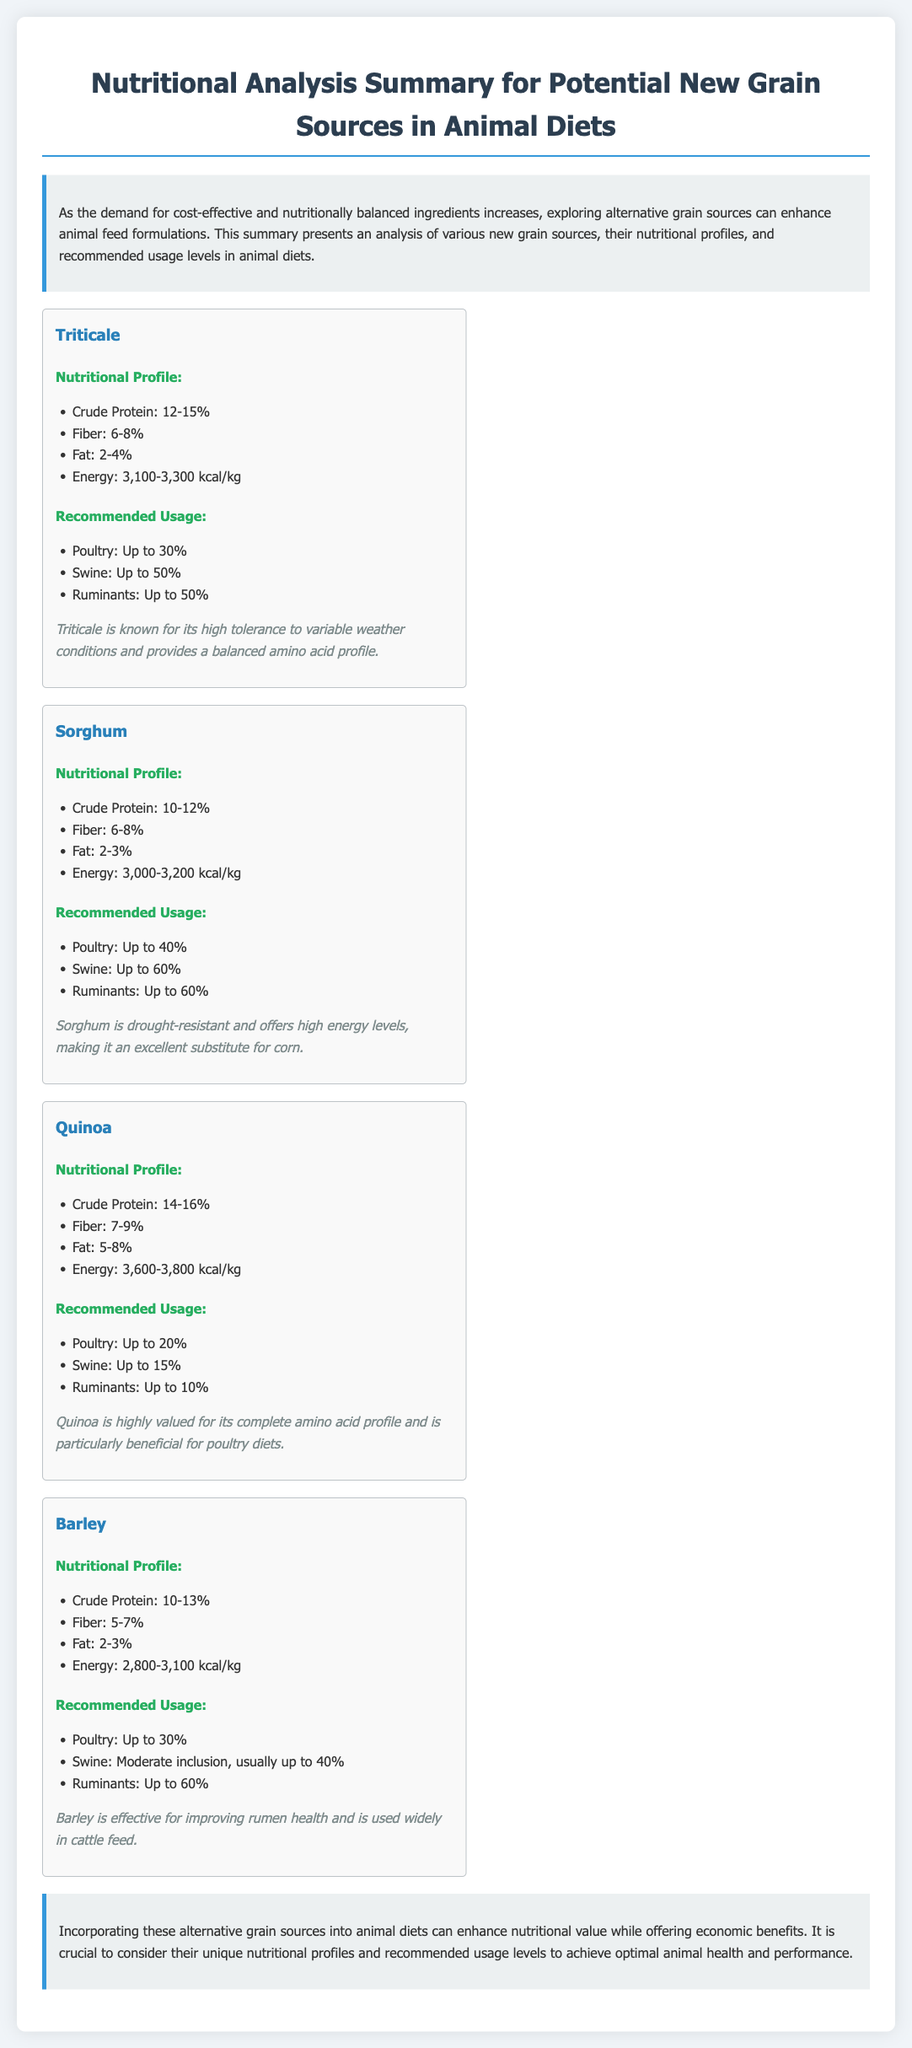What is the crude protein percentage range for Triticale? The crude protein percentage range for Triticale is given in the nutritional profile section of the document.
Answer: 12-15% What is the maximum recommended usage of Sorghum for Swine? The maximum recommended usage for Swine is listed under the recommended usage section for Sorghum.
Answer: Up to 60% Which grain source has the highest energy content? The energy content is specified in the nutritional profiles, and comparing them highlights which has the highest.
Answer: Quinoa What is the fiber percentage range for Barley? The fiber percentage range for Barley is outlined in the nutritional profile section.
Answer: 5-7% What is a benefit of using Quinoa in animal diets? The notes section provides insights into the benefits of using Quinoa in animal diets.
Answer: Complete amino acid profile What is the nutritional profile term associated with Sorghum? The nutritional profile for Sorghum is outlined using specific terms found in the document.
Answer: Crude Protein: 10-12% What grain sources are recommended for poultry diets? The document lists multiple grain sources under their usage recommendations for poultry.
Answer: Triticale, Sorghum, Quinoa, Barley How does Triticale compare to other grains in terms of weather tolerance? The notes about Triticale highlight its specific advantages related to weather tolerance compared to other grains.
Answer: High tolerance to variable weather conditions 